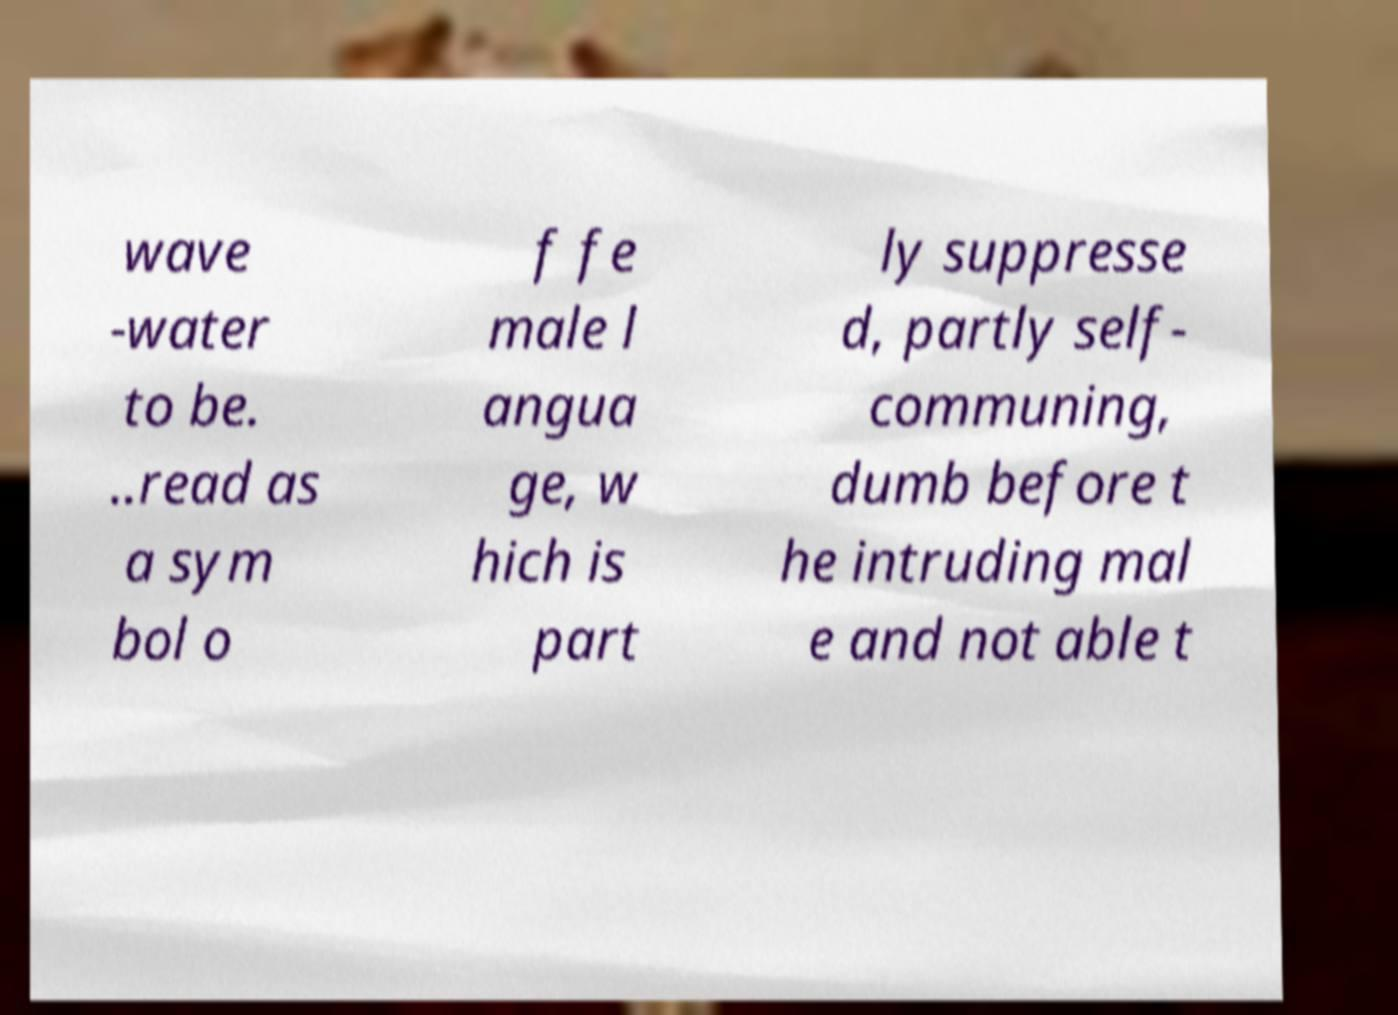What messages or text are displayed in this image? I need them in a readable, typed format. wave -water to be. ..read as a sym bol o f fe male l angua ge, w hich is part ly suppresse d, partly self- communing, dumb before t he intruding mal e and not able t 